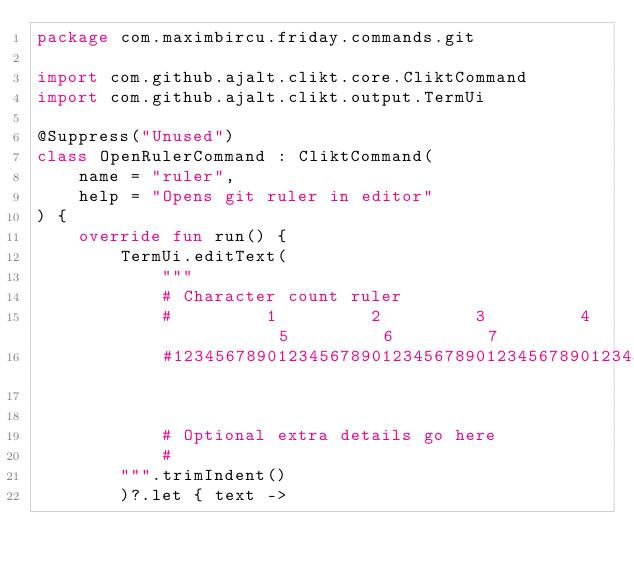Convert code to text. <code><loc_0><loc_0><loc_500><loc_500><_Kotlin_>package com.maximbircu.friday.commands.git

import com.github.ajalt.clikt.core.CliktCommand
import com.github.ajalt.clikt.output.TermUi

@Suppress("Unused")
class OpenRulerCommand : CliktCommand(
    name = "ruler",
    help = "Opens git ruler in editor"
) {
    override fun run() {
        TermUi.editText(
            """
            # Character count ruler
            #         1         2         3         4         5         6         7
            #123456789012345678901234567890123456789012345678901234567890123456789012
            

            # Optional extra details go here
            #
        """.trimIndent()
        )?.let { text -></code> 